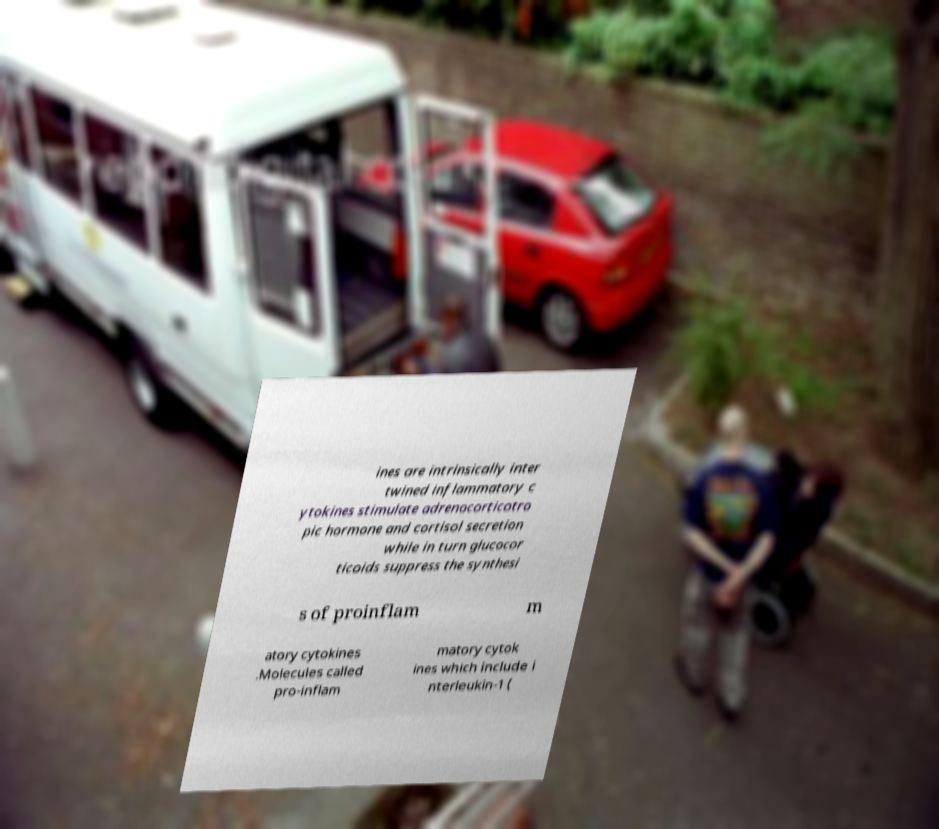Please read and relay the text visible in this image. What does it say? ines are intrinsically inter twined inflammatory c ytokines stimulate adrenocorticotro pic hormone and cortisol secretion while in turn glucocor ticoids suppress the synthesi s of proinflam m atory cytokines .Molecules called pro-inflam matory cytok ines which include i nterleukin-1 ( 